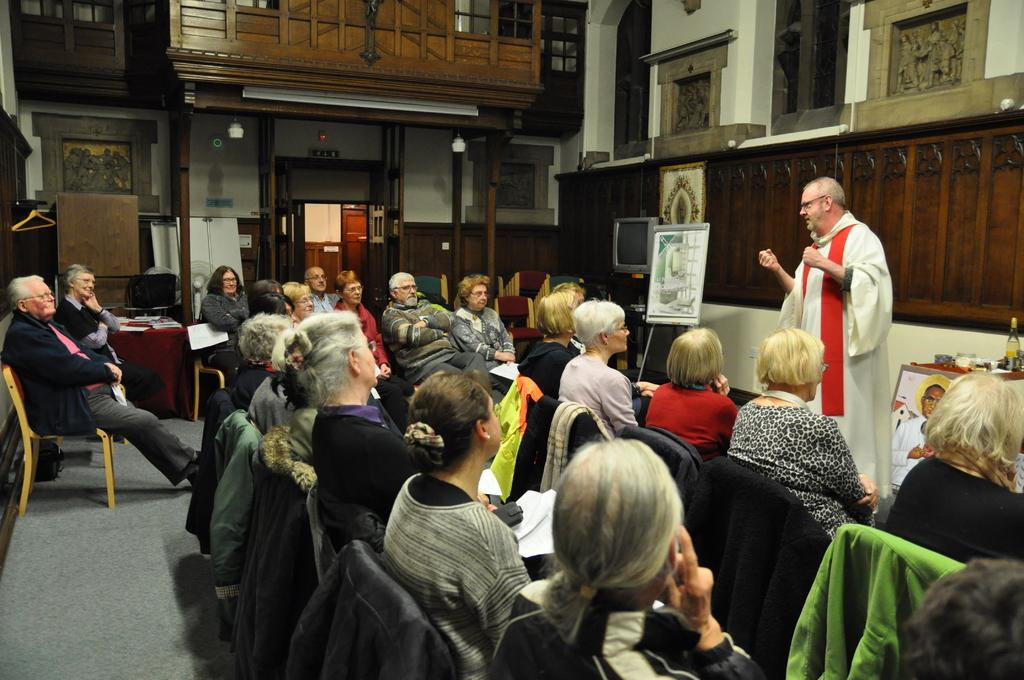What are the people in the image doing? The people in the image are sitting on chairs. What is the man in the image doing? The man in the image is standing. What is behind the man in the image? There is a wall behind the man. What can be seen in the background of the image? In the background, there is another wall with a door. What type of wound can be seen on the potato in the image? There is no potato present in the image, and therefore no wound can be observed. 